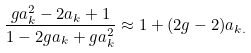Convert formula to latex. <formula><loc_0><loc_0><loc_500><loc_500>\frac { g a _ { k } ^ { 2 } - 2 a _ { k } + 1 } { 1 - 2 g a _ { k } + g a _ { k } ^ { 2 } } \approx 1 + ( 2 g - 2 ) a _ { k . }</formula> 